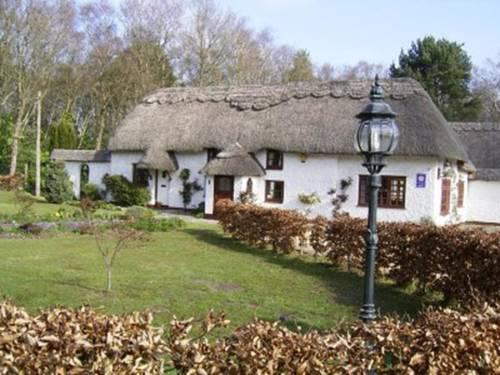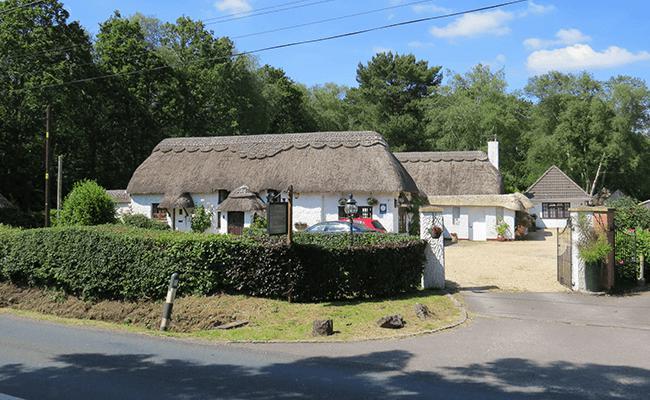The first image is the image on the left, the second image is the image on the right. Analyze the images presented: Is the assertion "One of the houses has a swimming pool." valid? Answer yes or no. No. The first image is the image on the left, the second image is the image on the right. For the images displayed, is the sentence "Patio furniture is in front of a house." factually correct? Answer yes or no. No. 